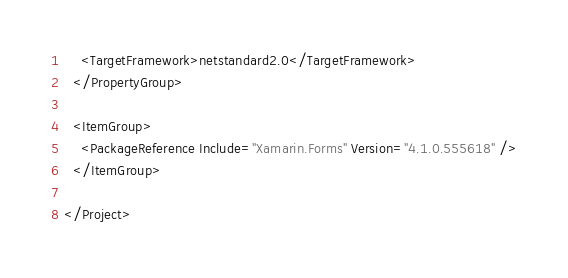<code> <loc_0><loc_0><loc_500><loc_500><_XML_>    <TargetFramework>netstandard2.0</TargetFramework>
  </PropertyGroup>

  <ItemGroup>
    <PackageReference Include="Xamarin.Forms" Version="4.1.0.555618" />
  </ItemGroup>

</Project>
</code> 